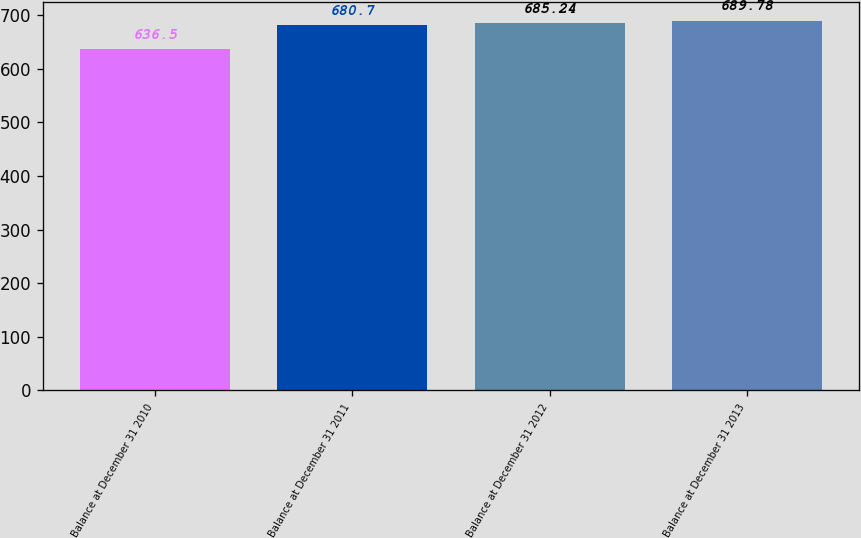Convert chart. <chart><loc_0><loc_0><loc_500><loc_500><bar_chart><fcel>Balance at December 31 2010<fcel>Balance at December 31 2011<fcel>Balance at December 31 2012<fcel>Balance at December 31 2013<nl><fcel>636.5<fcel>680.7<fcel>685.24<fcel>689.78<nl></chart> 